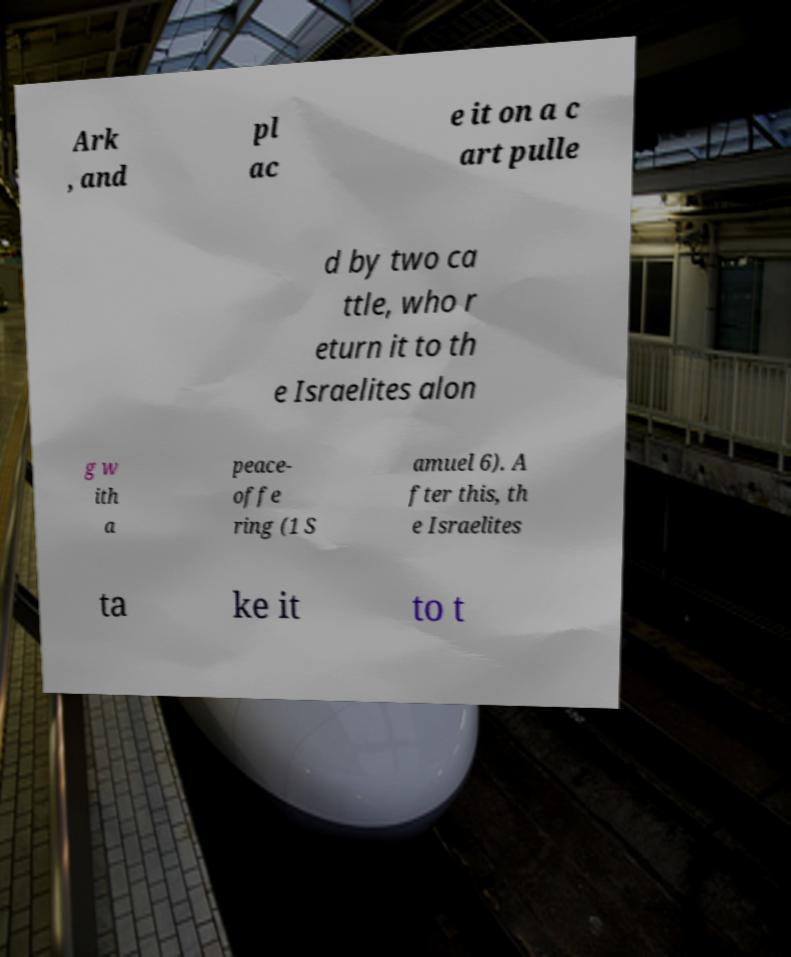Could you assist in decoding the text presented in this image and type it out clearly? Ark , and pl ac e it on a c art pulle d by two ca ttle, who r eturn it to th e Israelites alon g w ith a peace- offe ring (1 S amuel 6). A fter this, th e Israelites ta ke it to t 